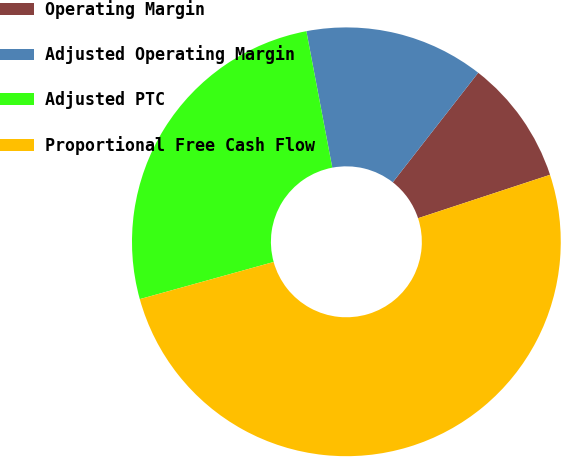Convert chart to OTSL. <chart><loc_0><loc_0><loc_500><loc_500><pie_chart><fcel>Operating Margin<fcel>Adjusted Operating Margin<fcel>Adjusted PTC<fcel>Proportional Free Cash Flow<nl><fcel>9.4%<fcel>13.53%<fcel>26.32%<fcel>50.75%<nl></chart> 